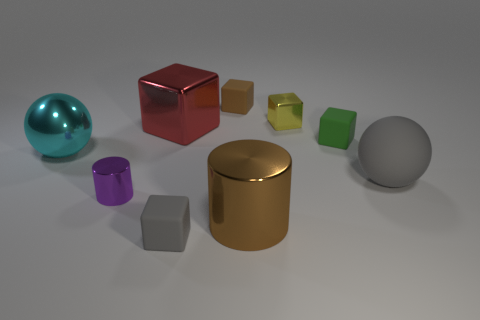What number of things are cyan metallic balls or things?
Provide a short and direct response. 9. There is a gray object that is in front of the large ball that is to the right of the green rubber block; what is it made of?
Your answer should be compact. Rubber. Is there a gray block made of the same material as the cyan ball?
Make the answer very short. No. What is the shape of the tiny thing that is in front of the big thing that is in front of the gray rubber object to the right of the tiny metal cube?
Provide a short and direct response. Cube. What is the tiny brown thing made of?
Ensure brevity in your answer.  Rubber. The other block that is the same material as the red block is what color?
Your response must be concise. Yellow. There is a matte object behind the small yellow shiny object; are there any green objects that are behind it?
Ensure brevity in your answer.  No. How many other objects are there of the same shape as the yellow metal object?
Your answer should be very brief. 4. Do the tiny metal thing that is in front of the tiny green matte object and the brown object that is left of the brown cylinder have the same shape?
Your answer should be very brief. No. There is a small block in front of the big metal thing to the right of the gray rubber cube; what number of big brown things are in front of it?
Your answer should be compact. 0. 